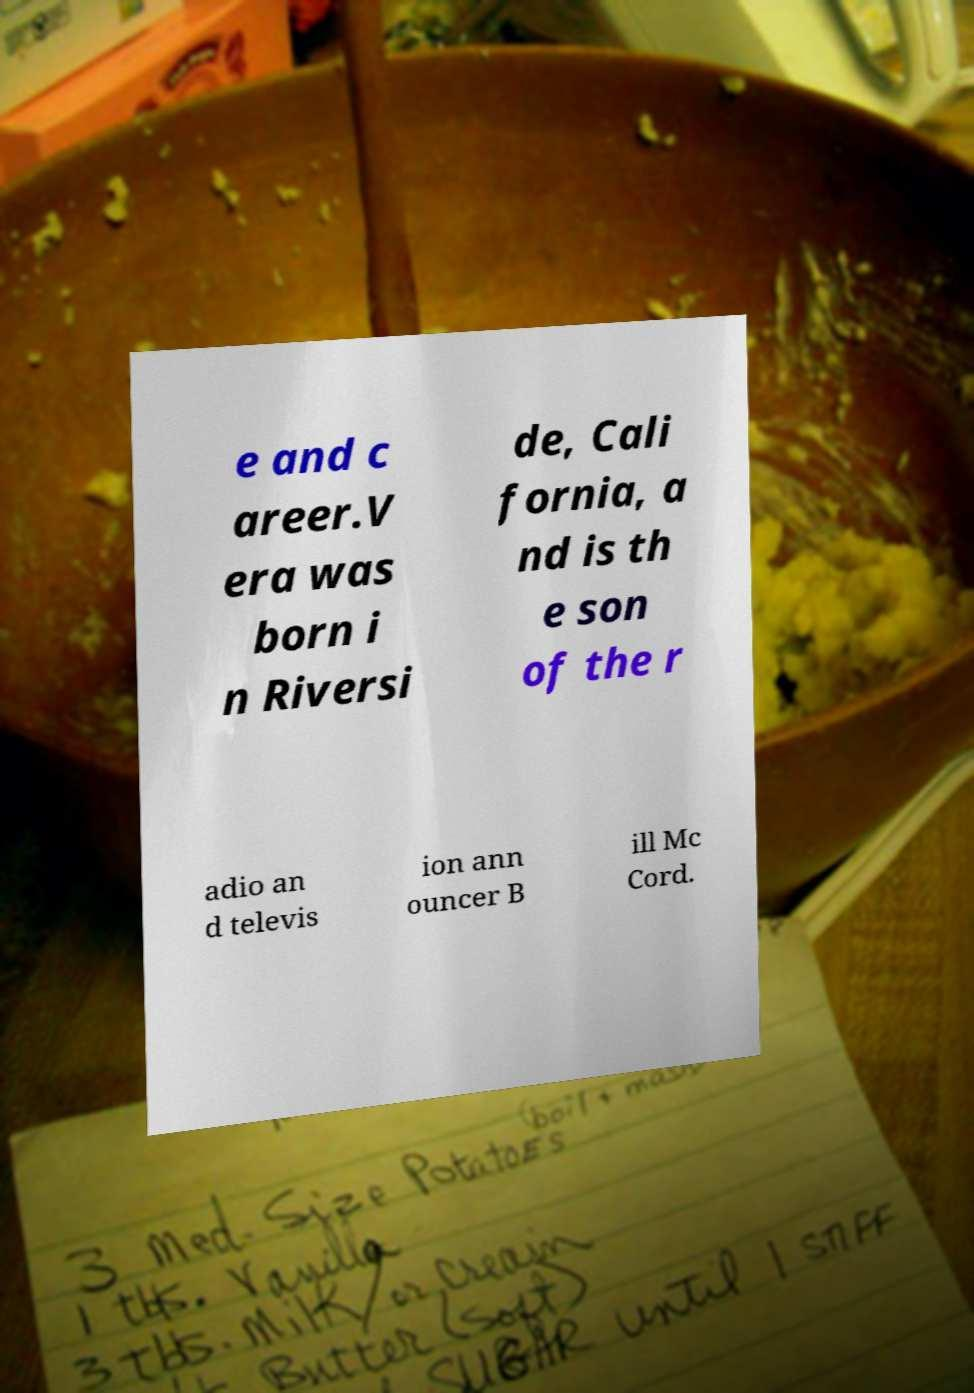Can you accurately transcribe the text from the provided image for me? e and c areer.V era was born i n Riversi de, Cali fornia, a nd is th e son of the r adio an d televis ion ann ouncer B ill Mc Cord. 